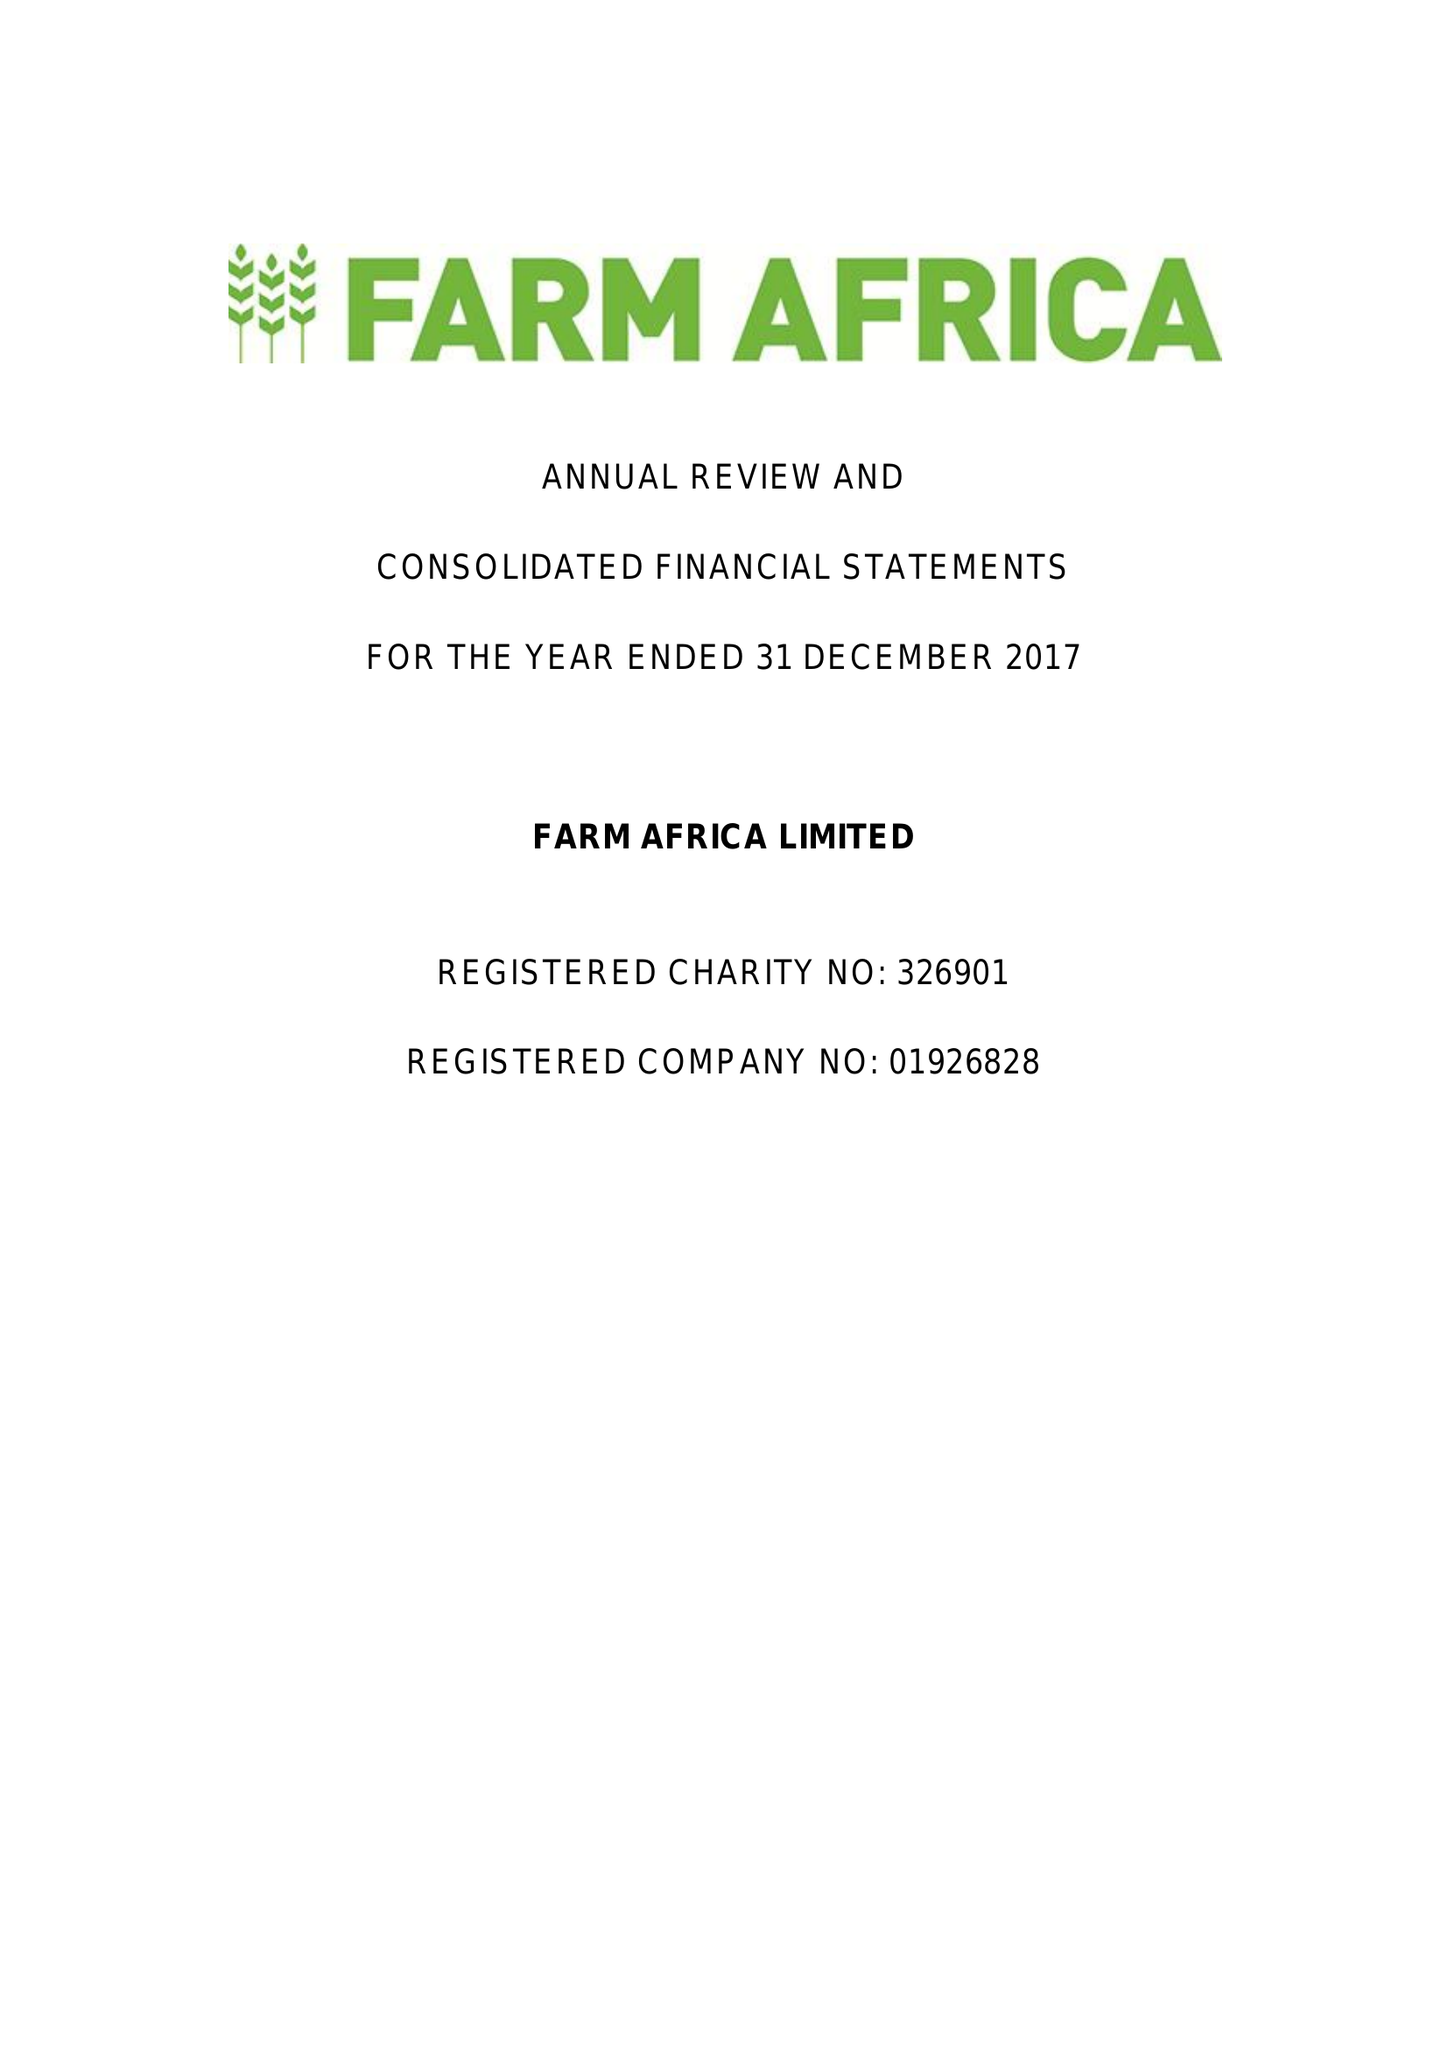What is the value for the address__street_line?
Answer the question using a single word or phrase. 140 LONDON WALL 